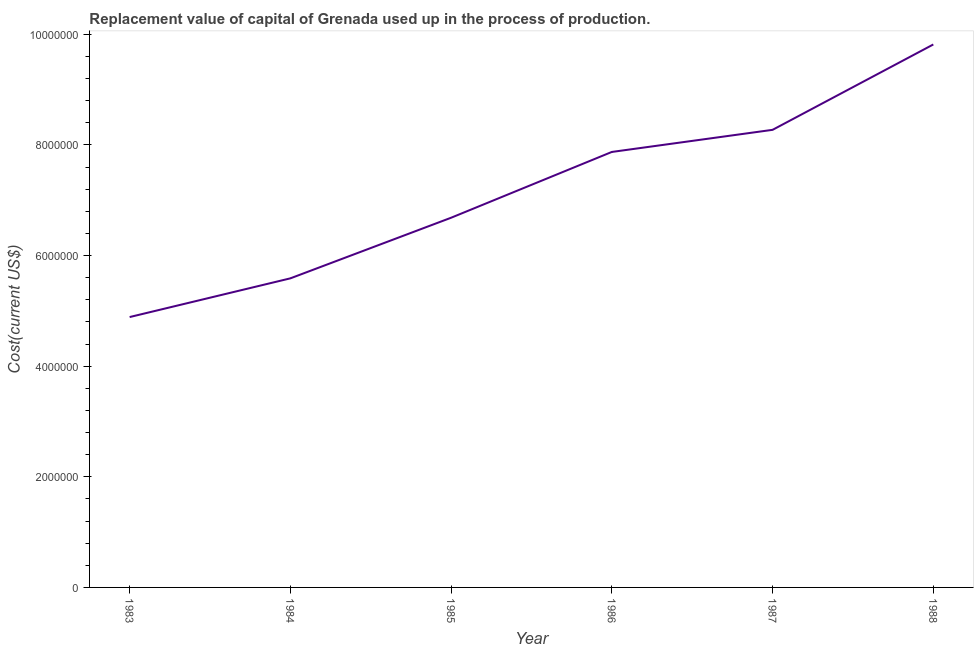What is the consumption of fixed capital in 1985?
Provide a short and direct response. 6.68e+06. Across all years, what is the maximum consumption of fixed capital?
Provide a short and direct response. 9.82e+06. Across all years, what is the minimum consumption of fixed capital?
Make the answer very short. 4.89e+06. What is the sum of the consumption of fixed capital?
Make the answer very short. 4.31e+07. What is the difference between the consumption of fixed capital in 1984 and 1987?
Keep it short and to the point. -2.68e+06. What is the average consumption of fixed capital per year?
Your answer should be very brief. 7.19e+06. What is the median consumption of fixed capital?
Provide a short and direct response. 7.28e+06. What is the ratio of the consumption of fixed capital in 1983 to that in 1984?
Offer a very short reply. 0.87. Is the consumption of fixed capital in 1984 less than that in 1985?
Give a very brief answer. Yes. Is the difference between the consumption of fixed capital in 1987 and 1988 greater than the difference between any two years?
Make the answer very short. No. What is the difference between the highest and the second highest consumption of fixed capital?
Your response must be concise. 1.54e+06. What is the difference between the highest and the lowest consumption of fixed capital?
Ensure brevity in your answer.  4.93e+06. Does the consumption of fixed capital monotonically increase over the years?
Ensure brevity in your answer.  Yes. How many lines are there?
Your response must be concise. 1. Are the values on the major ticks of Y-axis written in scientific E-notation?
Make the answer very short. No. Does the graph contain grids?
Give a very brief answer. No. What is the title of the graph?
Offer a terse response. Replacement value of capital of Grenada used up in the process of production. What is the label or title of the Y-axis?
Ensure brevity in your answer.  Cost(current US$). What is the Cost(current US$) of 1983?
Keep it short and to the point. 4.89e+06. What is the Cost(current US$) of 1984?
Your response must be concise. 5.59e+06. What is the Cost(current US$) in 1985?
Offer a terse response. 6.68e+06. What is the Cost(current US$) of 1986?
Offer a very short reply. 7.87e+06. What is the Cost(current US$) of 1987?
Ensure brevity in your answer.  8.27e+06. What is the Cost(current US$) of 1988?
Your response must be concise. 9.82e+06. What is the difference between the Cost(current US$) in 1983 and 1984?
Provide a short and direct response. -7.00e+05. What is the difference between the Cost(current US$) in 1983 and 1985?
Make the answer very short. -1.80e+06. What is the difference between the Cost(current US$) in 1983 and 1986?
Give a very brief answer. -2.99e+06. What is the difference between the Cost(current US$) in 1983 and 1987?
Your answer should be very brief. -3.38e+06. What is the difference between the Cost(current US$) in 1983 and 1988?
Make the answer very short. -4.93e+06. What is the difference between the Cost(current US$) in 1984 and 1985?
Your response must be concise. -1.10e+06. What is the difference between the Cost(current US$) in 1984 and 1986?
Ensure brevity in your answer.  -2.29e+06. What is the difference between the Cost(current US$) in 1984 and 1987?
Offer a very short reply. -2.68e+06. What is the difference between the Cost(current US$) in 1984 and 1988?
Give a very brief answer. -4.23e+06. What is the difference between the Cost(current US$) in 1985 and 1986?
Your answer should be compact. -1.19e+06. What is the difference between the Cost(current US$) in 1985 and 1987?
Give a very brief answer. -1.59e+06. What is the difference between the Cost(current US$) in 1985 and 1988?
Provide a short and direct response. -3.13e+06. What is the difference between the Cost(current US$) in 1986 and 1987?
Offer a very short reply. -4.00e+05. What is the difference between the Cost(current US$) in 1986 and 1988?
Ensure brevity in your answer.  -1.94e+06. What is the difference between the Cost(current US$) in 1987 and 1988?
Give a very brief answer. -1.54e+06. What is the ratio of the Cost(current US$) in 1983 to that in 1985?
Ensure brevity in your answer.  0.73. What is the ratio of the Cost(current US$) in 1983 to that in 1986?
Your answer should be compact. 0.62. What is the ratio of the Cost(current US$) in 1983 to that in 1987?
Make the answer very short. 0.59. What is the ratio of the Cost(current US$) in 1983 to that in 1988?
Provide a succinct answer. 0.5. What is the ratio of the Cost(current US$) in 1984 to that in 1985?
Provide a succinct answer. 0.84. What is the ratio of the Cost(current US$) in 1984 to that in 1986?
Offer a very short reply. 0.71. What is the ratio of the Cost(current US$) in 1984 to that in 1987?
Offer a terse response. 0.68. What is the ratio of the Cost(current US$) in 1984 to that in 1988?
Give a very brief answer. 0.57. What is the ratio of the Cost(current US$) in 1985 to that in 1986?
Ensure brevity in your answer.  0.85. What is the ratio of the Cost(current US$) in 1985 to that in 1987?
Your answer should be very brief. 0.81. What is the ratio of the Cost(current US$) in 1985 to that in 1988?
Ensure brevity in your answer.  0.68. What is the ratio of the Cost(current US$) in 1986 to that in 1988?
Your response must be concise. 0.8. What is the ratio of the Cost(current US$) in 1987 to that in 1988?
Provide a succinct answer. 0.84. 